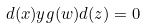<formula> <loc_0><loc_0><loc_500><loc_500>d ( x ) y g ( w ) d ( z ) = 0</formula> 